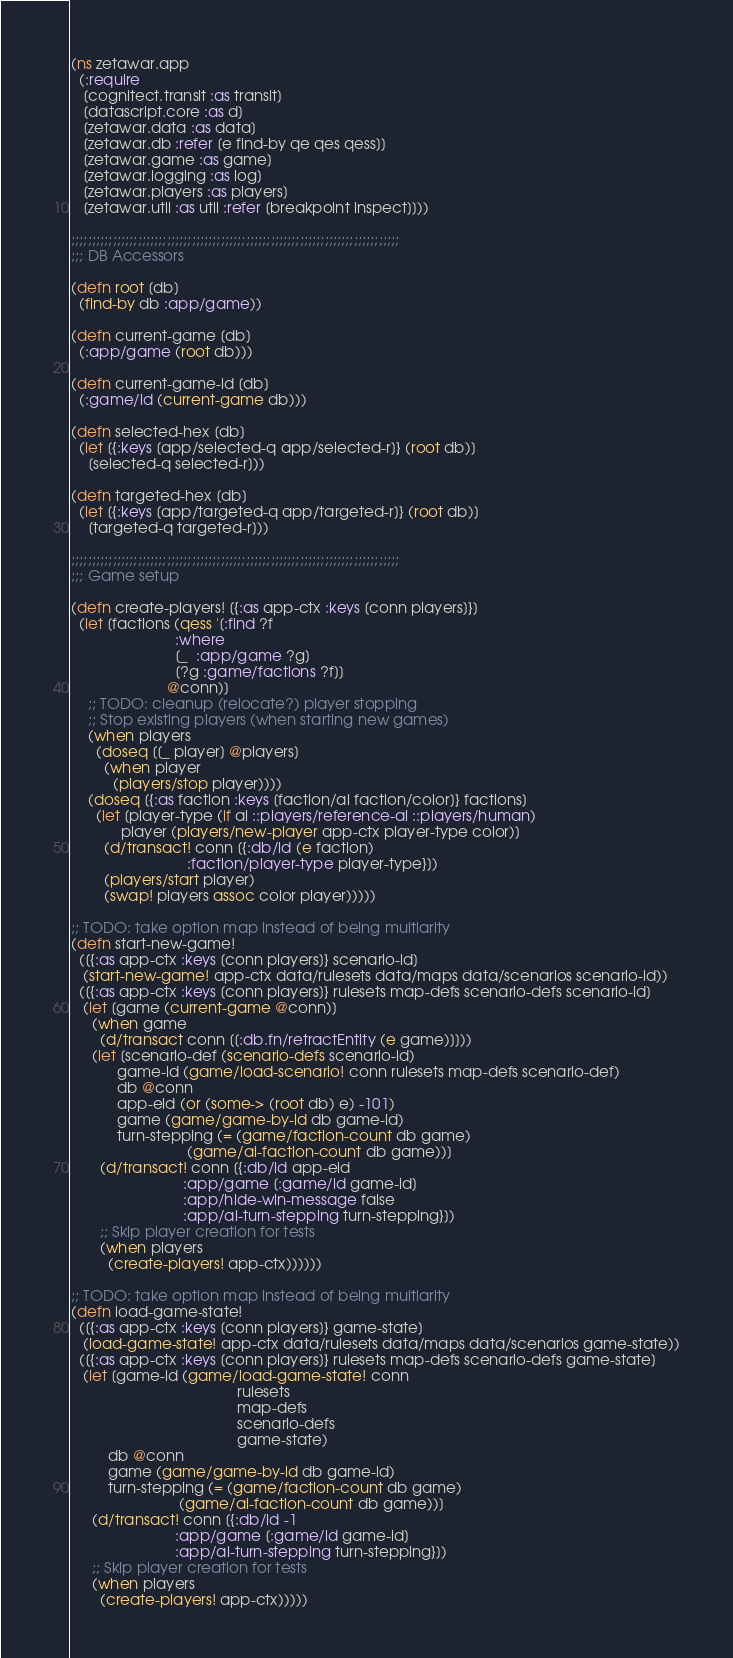Convert code to text. <code><loc_0><loc_0><loc_500><loc_500><_Clojure_>(ns zetawar.app
  (:require
   [cognitect.transit :as transit]
   [datascript.core :as d]
   [zetawar.data :as data]
   [zetawar.db :refer [e find-by qe qes qess]]
   [zetawar.game :as game]
   [zetawar.logging :as log]
   [zetawar.players :as players]
   [zetawar.util :as util :refer [breakpoint inspect]]))

;;;;;;;;;;;;;;;;;;;;;;;;;;;;;;;;;;;;;;;;;;;;;;;;;;;;;;;;;;;;;;;;;;;;;;;;;;;;;;;
;;; DB Accessors

(defn root [db]
  (find-by db :app/game))

(defn current-game [db]
  (:app/game (root db)))

(defn current-game-id [db]
  (:game/id (current-game db)))

(defn selected-hex [db]
  (let [{:keys [app/selected-q app/selected-r]} (root db)]
    [selected-q selected-r]))

(defn targeted-hex [db]
  (let [{:keys [app/targeted-q app/targeted-r]} (root db)]
    [targeted-q targeted-r]))

;;;;;;;;;;;;;;;;;;;;;;;;;;;;;;;;;;;;;;;;;;;;;;;;;;;;;;;;;;;;;;;;;;;;;;;;;;;;;;;
;;; Game setup

(defn create-players! [{:as app-ctx :keys [conn players]}]
  (let [factions (qess '[:find ?f
                         :where
                         [_  :app/game ?g]
                         [?g :game/factions ?f]]
                       @conn)]
    ;; TODO: cleanup (relocate?) player stopping
    ;; Stop existing players (when starting new games)
    (when players
      (doseq [[_ player] @players]
        (when player
          (players/stop player))))
    (doseq [{:as faction :keys [faction/ai faction/color]} factions]
      (let [player-type (if ai ::players/reference-ai ::players/human)
            player (players/new-player app-ctx player-type color)]
        (d/transact! conn [{:db/id (e faction)
                            :faction/player-type player-type}])
        (players/start player)
        (swap! players assoc color player)))))

;; TODO: take option map instead of being multiarity
(defn start-new-game!
  ([{:as app-ctx :keys [conn players]} scenario-id]
   (start-new-game! app-ctx data/rulesets data/maps data/scenarios scenario-id))
  ([{:as app-ctx :keys [conn players]} rulesets map-defs scenario-defs scenario-id]
   (let [game (current-game @conn)]
     (when game
       (d/transact conn [[:db.fn/retractEntity (e game)]]))
     (let [scenario-def (scenario-defs scenario-id)
           game-id (game/load-scenario! conn rulesets map-defs scenario-def)
           db @conn
           app-eid (or (some-> (root db) e) -101)
           game (game/game-by-id db game-id)
           turn-stepping (= (game/faction-count db game)
                            (game/ai-faction-count db game))]
       (d/transact! conn [{:db/id app-eid
                           :app/game [:game/id game-id]
                           :app/hide-win-message false
                           :app/ai-turn-stepping turn-stepping}])
       ;; Skip player creation for tests
       (when players
         (create-players! app-ctx))))))

;; TODO: take option map instead of being multiarity
(defn load-game-state!
  ([{:as app-ctx :keys [conn players]} game-state]
   (load-game-state! app-ctx data/rulesets data/maps data/scenarios game-state))
  ([{:as app-ctx :keys [conn players]} rulesets map-defs scenario-defs game-state]
   (let [game-id (game/load-game-state! conn
                                        rulesets
                                        map-defs
                                        scenario-defs
                                        game-state)
         db @conn
         game (game/game-by-id db game-id)
         turn-stepping (= (game/faction-count db game)
                          (game/ai-faction-count db game))]
     (d/transact! conn [{:db/id -1
                         :app/game [:game/id game-id]
                         :app/ai-turn-stepping turn-stepping}])
     ;; Skip player creation for tests
     (when players
       (create-players! app-ctx)))))
</code> 